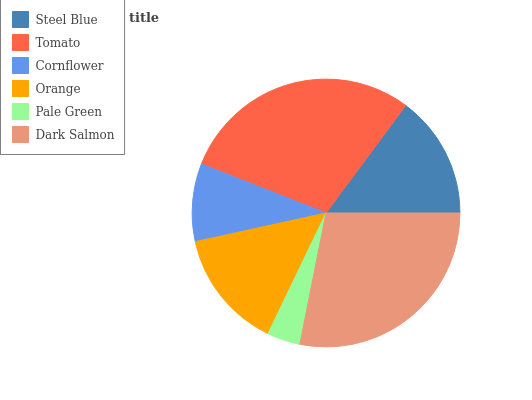Is Pale Green the minimum?
Answer yes or no. Yes. Is Tomato the maximum?
Answer yes or no. Yes. Is Cornflower the minimum?
Answer yes or no. No. Is Cornflower the maximum?
Answer yes or no. No. Is Tomato greater than Cornflower?
Answer yes or no. Yes. Is Cornflower less than Tomato?
Answer yes or no. Yes. Is Cornflower greater than Tomato?
Answer yes or no. No. Is Tomato less than Cornflower?
Answer yes or no. No. Is Steel Blue the high median?
Answer yes or no. Yes. Is Orange the low median?
Answer yes or no. Yes. Is Orange the high median?
Answer yes or no. No. Is Tomato the low median?
Answer yes or no. No. 